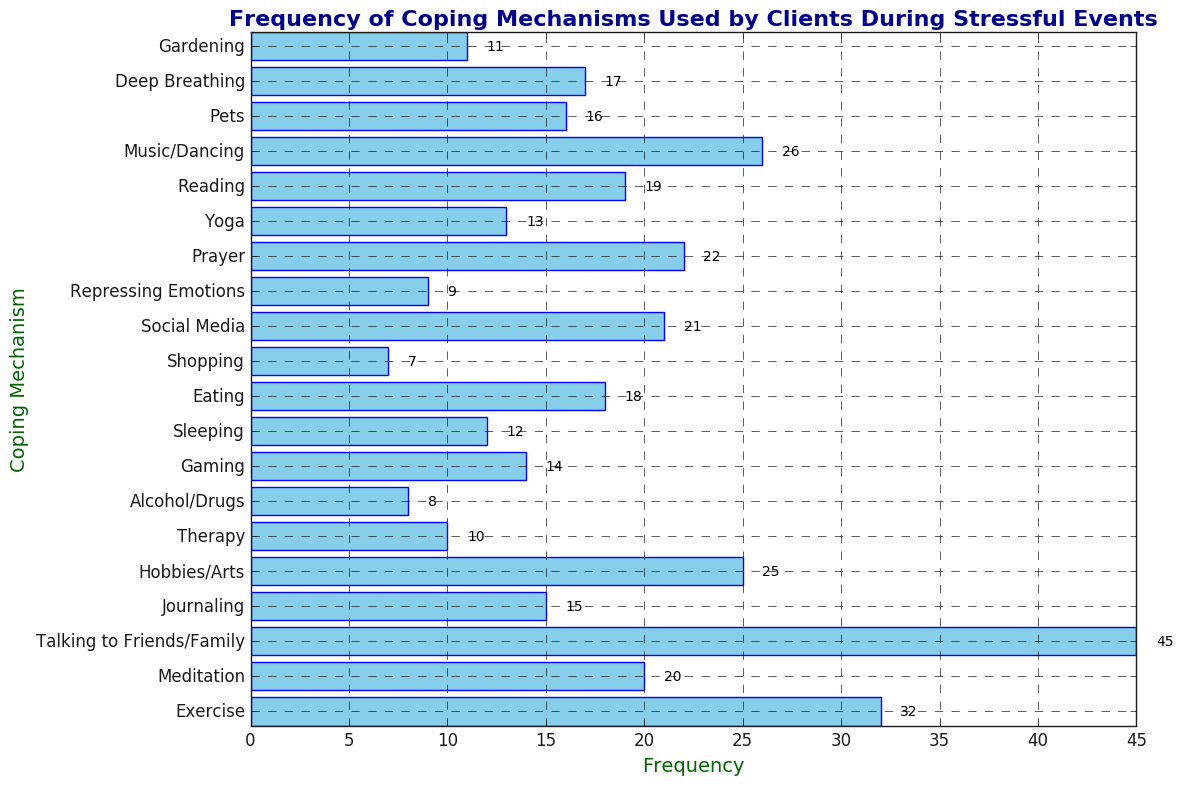What coping mechanism is used the most frequently? Referring to the bar that extends the farthest to the right, "Talking to Friends/Family" has the highest frequency at 45.
Answer: Talking to Friends/Family Which coping mechanism has a frequency closest to 20? The bar labeled "Meditation" extends to a frequency of 20, which is the exact value.
Answer: Meditation What is the sum of the frequencies for "Meditation," "Reading," and "Prayer"? The frequencies for "Meditation," "Reading," and "Prayer" are 20, 19, and 22 respectively. Summing these values gives 20 + 19 + 22 = 61.
Answer: 61 Which coping mechanisms have a frequency lower than 10? By scanning the bars to the left of the frequency of 10, "Alcohol/Drugs," "Repressing Emotions," and "Shopping" all have frequencies lower than 10, specifically 8, 9, and 7 respectively.
Answer: Alcohol/Drugs, Repressing Emotions, Shopping Is "Gaming" used more frequently than "Journaling"? "Gaming" has a frequency of 14, whereas "Journaling" has a frequency of 15. Therefore, "Gaming" is used less frequently than "Journaling".
Answer: No What is the difference in the frequency of "Exercise" and "Music/Dancing"? "Exercise" has a frequency of 32 and "Music/Dancing" has a frequency of 26. The difference is 32 - 26 = 6.
Answer: 6 How many coping mechanisms have a frequency that is a multiple of 5? The coping mechanisms with frequencies that are multiples of 5 are "Exercise" (32), "Journaling" (15), and "Hobbies/Arts" (25), making a total of 3 coping mechanisms.
Answer: 3 What is the average frequency of "Pets," "Deep Breathing," and "Gardening"? Adding the frequencies for "Pets," "Deep Breathing," and "Gardening" gives 16 + 17 + 11 = 44. Dividing by 3, the average frequency is 44/3 ≈ 14.67.
Answer: 14.67 Which coping mechanism has the same frequency as "Social Media"? "Prayer" also has a frequency of 22, which is the same as "Social Media".
Answer: Prayer 